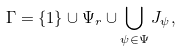<formula> <loc_0><loc_0><loc_500><loc_500>\Gamma = \{ 1 \} \cup \Psi _ { r } \cup \bigcup _ { \psi \in \Psi } J _ { \psi } ,</formula> 